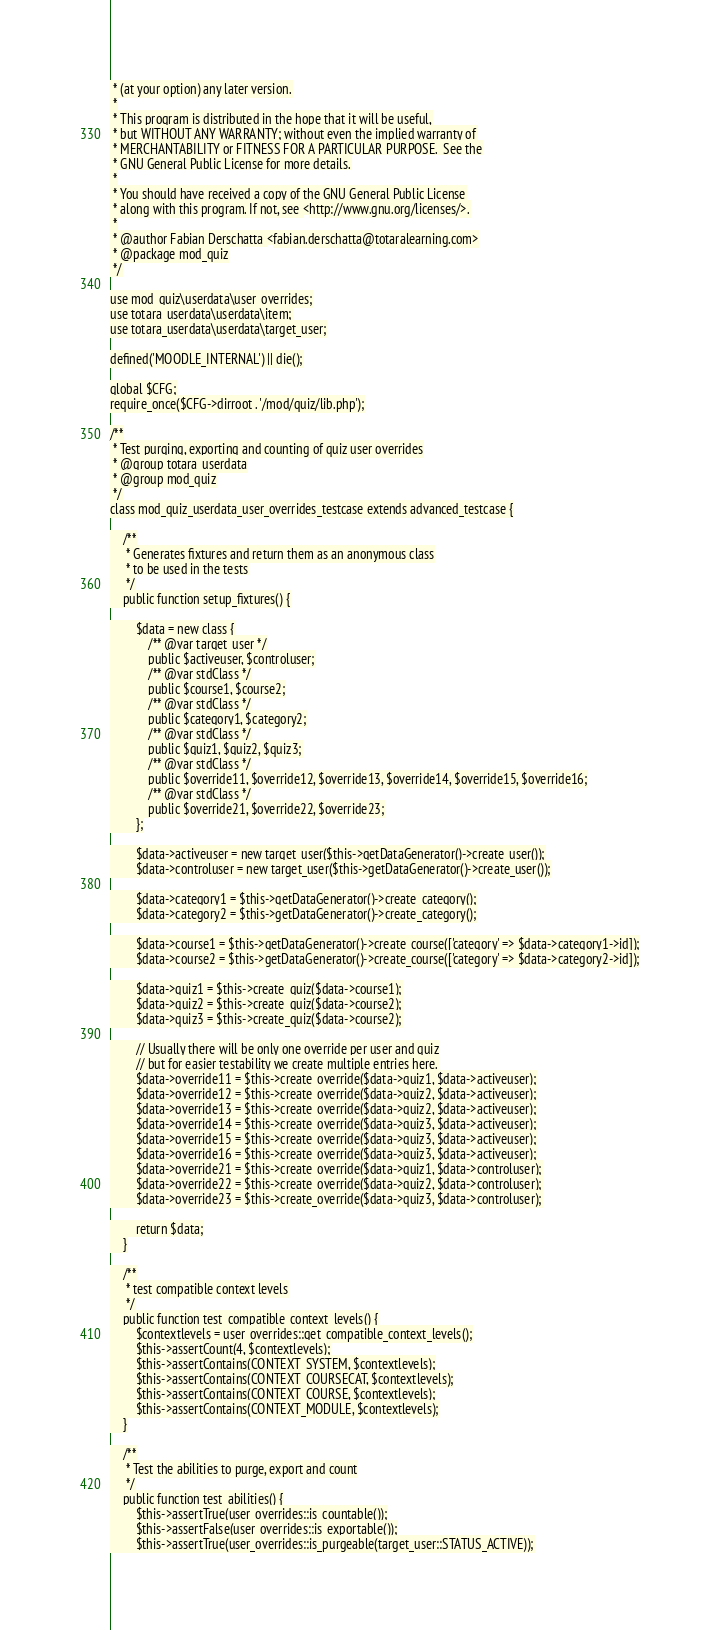Convert code to text. <code><loc_0><loc_0><loc_500><loc_500><_PHP_> * (at your option) any later version.
 *
 * This program is distributed in the hope that it will be useful,
 * but WITHOUT ANY WARRANTY; without even the implied warranty of
 * MERCHANTABILITY or FITNESS FOR A PARTICULAR PURPOSE.  See the
 * GNU General Public License for more details.
 *
 * You should have received a copy of the GNU General Public License
 * along with this program. If not, see <http://www.gnu.org/licenses/>.
 *
 * @author Fabian Derschatta <fabian.derschatta@totaralearning.com>
 * @package mod_quiz
 */

use mod_quiz\userdata\user_overrides;
use totara_userdata\userdata\item;
use totara_userdata\userdata\target_user;

defined('MOODLE_INTERNAL') || die();

global $CFG;
require_once($CFG->dirroot . '/mod/quiz/lib.php');

/**
 * Test purging, exporting and counting of quiz user overrides
 * @group totara_userdata
 * @group mod_quiz
 */
class mod_quiz_userdata_user_overrides_testcase extends advanced_testcase {

    /**
     * Generates fixtures and return them as an anonymous class
     * to be used in the tests
     */
    public function setup_fixtures() {

        $data = new class {
            /** @var target_user */
            public $activeuser, $controluser;
            /** @var stdClass */
            public $course1, $course2;
            /** @var stdClass */
            public $category1, $category2;
            /** @var stdClass */
            public $quiz1, $quiz2, $quiz3;
            /** @var stdClass */
            public $override11, $override12, $override13, $override14, $override15, $override16;
            /** @var stdClass */
            public $override21, $override22, $override23;
        };

        $data->activeuser = new target_user($this->getDataGenerator()->create_user());
        $data->controluser = new target_user($this->getDataGenerator()->create_user());

        $data->category1 = $this->getDataGenerator()->create_category();
        $data->category2 = $this->getDataGenerator()->create_category();

        $data->course1 = $this->getDataGenerator()->create_course(['category' => $data->category1->id]);
        $data->course2 = $this->getDataGenerator()->create_course(['category' => $data->category2->id]);

        $data->quiz1 = $this->create_quiz($data->course1);
        $data->quiz2 = $this->create_quiz($data->course2);
        $data->quiz3 = $this->create_quiz($data->course2);

        // Usually there will be only one override per user and quiz
        // but for easier testability we create multiple entries here.
        $data->override11 = $this->create_override($data->quiz1, $data->activeuser);
        $data->override12 = $this->create_override($data->quiz2, $data->activeuser);
        $data->override13 = $this->create_override($data->quiz2, $data->activeuser);
        $data->override14 = $this->create_override($data->quiz3, $data->activeuser);
        $data->override15 = $this->create_override($data->quiz3, $data->activeuser);
        $data->override16 = $this->create_override($data->quiz3, $data->activeuser);
        $data->override21 = $this->create_override($data->quiz1, $data->controluser);
        $data->override22 = $this->create_override($data->quiz2, $data->controluser);
        $data->override23 = $this->create_override($data->quiz3, $data->controluser);

        return $data;
    }

    /**
     * test compatible context levels
     */
    public function test_compatible_context_levels() {
        $contextlevels = user_overrides::get_compatible_context_levels();
        $this->assertCount(4, $contextlevels);
        $this->assertContains(CONTEXT_SYSTEM, $contextlevels);
        $this->assertContains(CONTEXT_COURSECAT, $contextlevels);
        $this->assertContains(CONTEXT_COURSE, $contextlevels);
        $this->assertContains(CONTEXT_MODULE, $contextlevels);
    }

    /**
     * Test the abilities to purge, export and count
     */
    public function test_abilities() {
        $this->assertTrue(user_overrides::is_countable());
        $this->assertFalse(user_overrides::is_exportable());
        $this->assertTrue(user_overrides::is_purgeable(target_user::STATUS_ACTIVE));</code> 